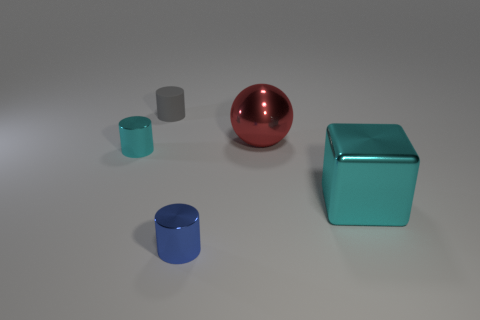Add 1 big cyan blocks. How many objects exist? 6 Subtract all cubes. How many objects are left? 4 Subtract all blue metallic objects. Subtract all blue metal things. How many objects are left? 3 Add 1 matte cylinders. How many matte cylinders are left? 2 Add 3 gray rubber objects. How many gray rubber objects exist? 4 Subtract 1 red spheres. How many objects are left? 4 